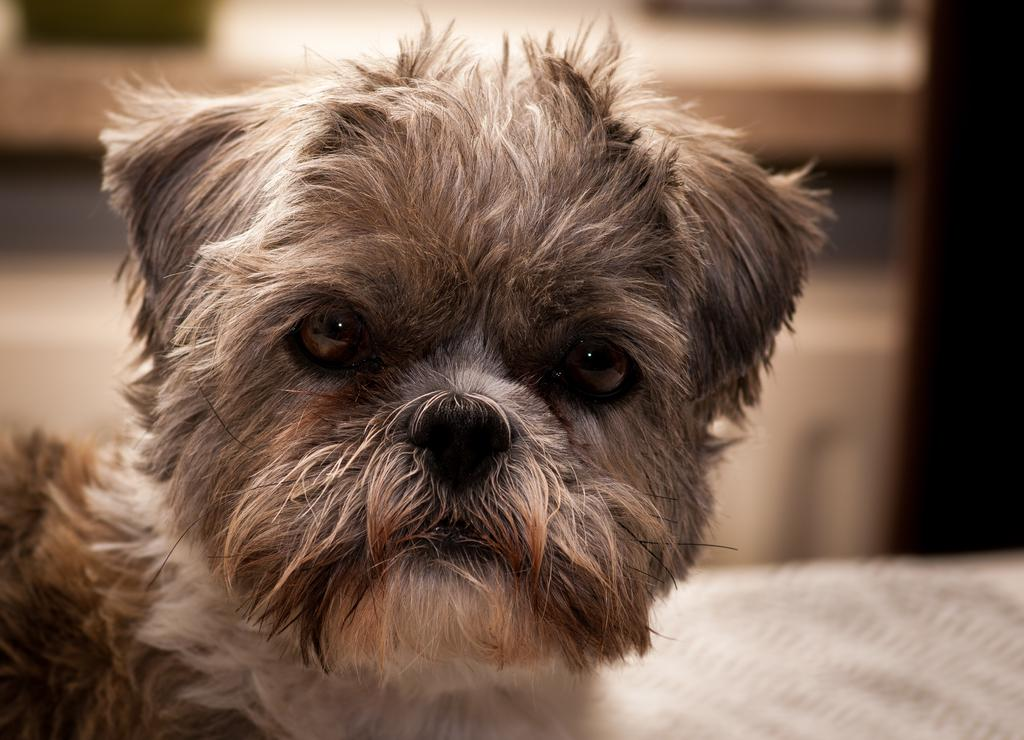What type of animal is in the picture? There is a dog in the picture. Can you describe the background of the picture? The background of the picture is blurry. What flavor of string is the dog holding in the picture? There is no string present in the image, and therefore no flavor can be determined. 